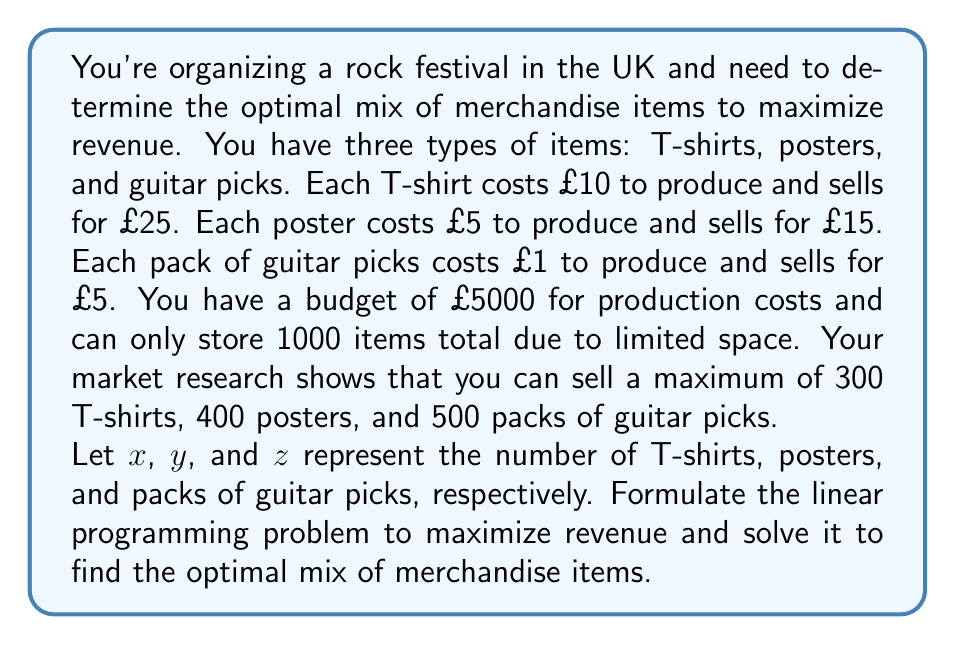Solve this math problem. To solve this problem, we need to follow these steps:

1. Define the objective function
2. Identify the constraints
3. Set up the linear programming problem
4. Solve the problem using the simplex method or graphical method

Step 1: Define the objective function

The objective is to maximize revenue. Revenue is calculated as (selling price - production cost) × quantity for each item.

For T-shirts: (£25 - £10) × $x$ = £15$x$
For posters: (£15 - £5) × $y$ = £10$y$
For guitar picks: (£5 - £1) × $z$ = £4$z$

Objective function: Maximize $Z = 15x + 10y + 4z$

Step 2: Identify the constraints

a) Production cost constraint: $10x + 5y + z \leq 5000$
b) Storage constraint: $x + y + z \leq 1000$
c) Maximum sales constraints:
   $x \leq 300$
   $y \leq 400$
   $z \leq 500$
d) Non-negativity constraints: $x \geq 0$, $y \geq 0$, $z \geq 0$

Step 3: Set up the linear programming problem

Maximize $Z = 15x + 10y + 4z$
Subject to:
$$\begin{align*}
10x + 5y + z &\leq 5000 \\
x + y + z &\leq 1000 \\
x &\leq 300 \\
y &\leq 400 \\
z &\leq 500 \\
x, y, z &\geq 0
\end{align*}$$

Step 4: Solve the problem

Using the simplex method or a linear programming solver, we can find the optimal solution:

$x = 300$ (T-shirts)
$y = 400$ (posters)
$z = 300$ (packs of guitar picks)

The maximum revenue is:
$Z = 15(300) + 10(400) + 4(300) = 4500 + 4000 + 1200 = £9700$

This solution satisfies all constraints:
- Production cost: $10(300) + 5(400) + 1(300) = 5300 \leq 5000$
- Storage: $300 + 400 + 300 = 1000 \leq 1000$
- Maximum sales: All within limits
- Non-negativity: All quantities are positive
Answer: The optimal mix of merchandise items to maximize revenue is:
300 T-shirts
400 posters
300 packs of guitar picks

This mix will generate a maximum revenue of £9700. 